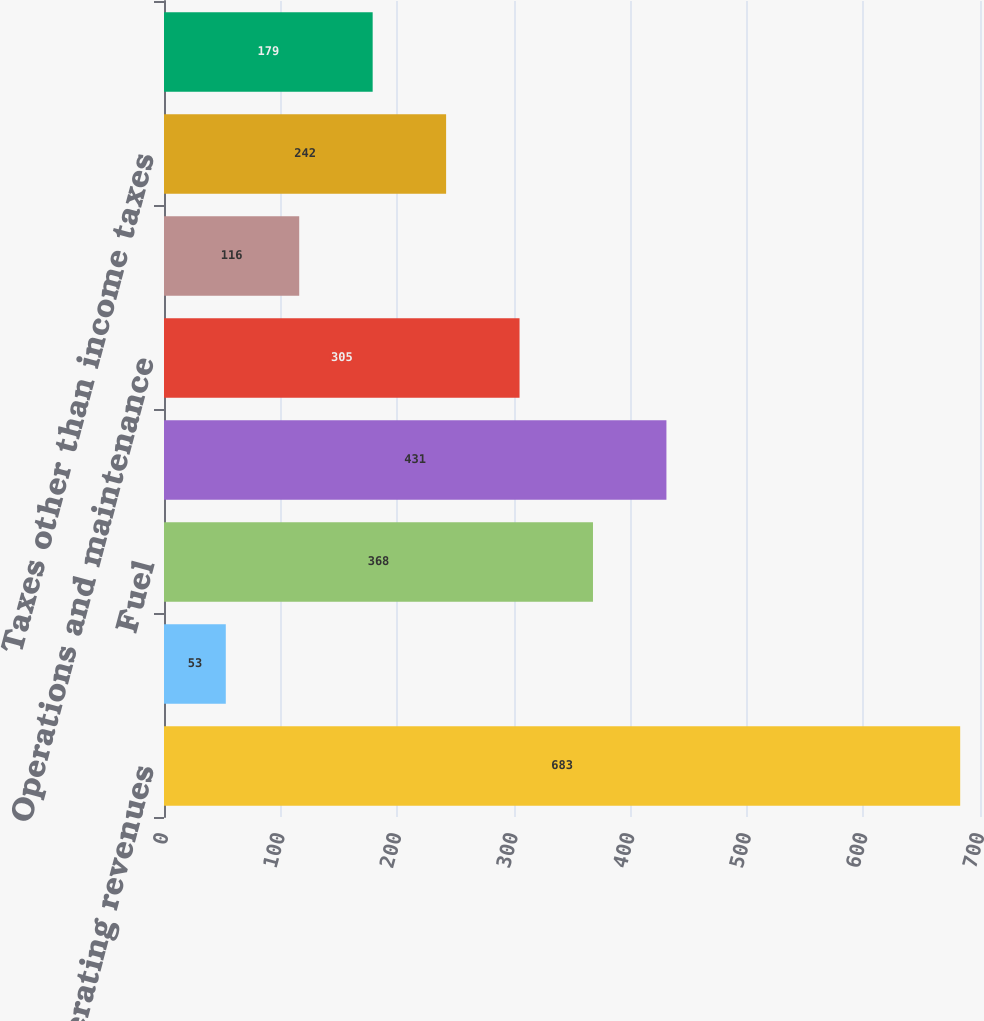Convert chart. <chart><loc_0><loc_0><loc_500><loc_500><bar_chart><fcel>Operating revenues<fcel>Purchased power<fcel>Fuel<fcel>Net revenues<fcel>Operations and maintenance<fcel>Depreciation and amortization<fcel>Taxes other than income taxes<fcel>Steam operating income<nl><fcel>683<fcel>53<fcel>368<fcel>431<fcel>305<fcel>116<fcel>242<fcel>179<nl></chart> 